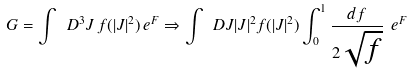<formula> <loc_0><loc_0><loc_500><loc_500>G = \int \ D ^ { 3 } J \, f ( | J | ^ { 2 } ) \, e ^ { F } \Rightarrow \int \ D J | J | ^ { 2 } f ( | J | ^ { 2 } ) \int ^ { 1 } _ { 0 } \frac { d f } { 2 \sqrt { f } } \ e ^ { F }</formula> 